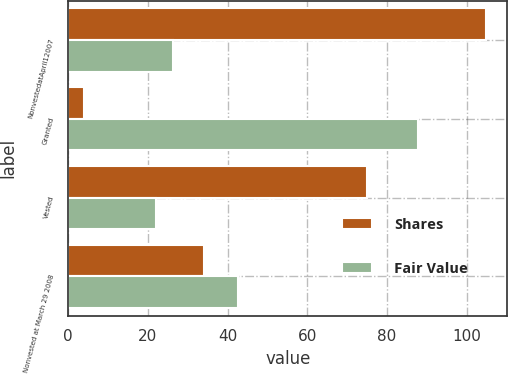Convert chart. <chart><loc_0><loc_0><loc_500><loc_500><stacked_bar_chart><ecel><fcel>NonvestedatApril12007<fcel>Granted<fcel>Vested<fcel>Nonvested at March 29 2008<nl><fcel>Shares<fcel>105<fcel>4<fcel>75<fcel>34<nl><fcel>Fair Value<fcel>26.25<fcel>87.85<fcel>21.97<fcel>42.6<nl></chart> 